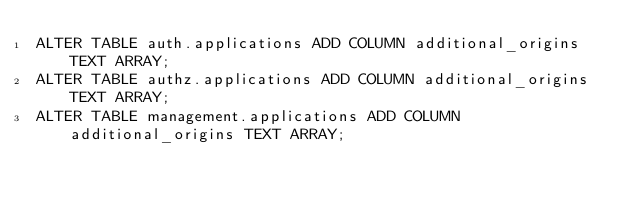<code> <loc_0><loc_0><loc_500><loc_500><_SQL_>ALTER TABLE auth.applications ADD COLUMN additional_origins TEXT ARRAY;
ALTER TABLE authz.applications ADD COLUMN additional_origins TEXT ARRAY;
ALTER TABLE management.applications ADD COLUMN additional_origins TEXT ARRAY;</code> 